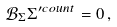Convert formula to latex. <formula><loc_0><loc_0><loc_500><loc_500>\mathcal { B } _ { \Sigma } \Sigma ^ { \prime c o u n t } = 0 \, ,</formula> 